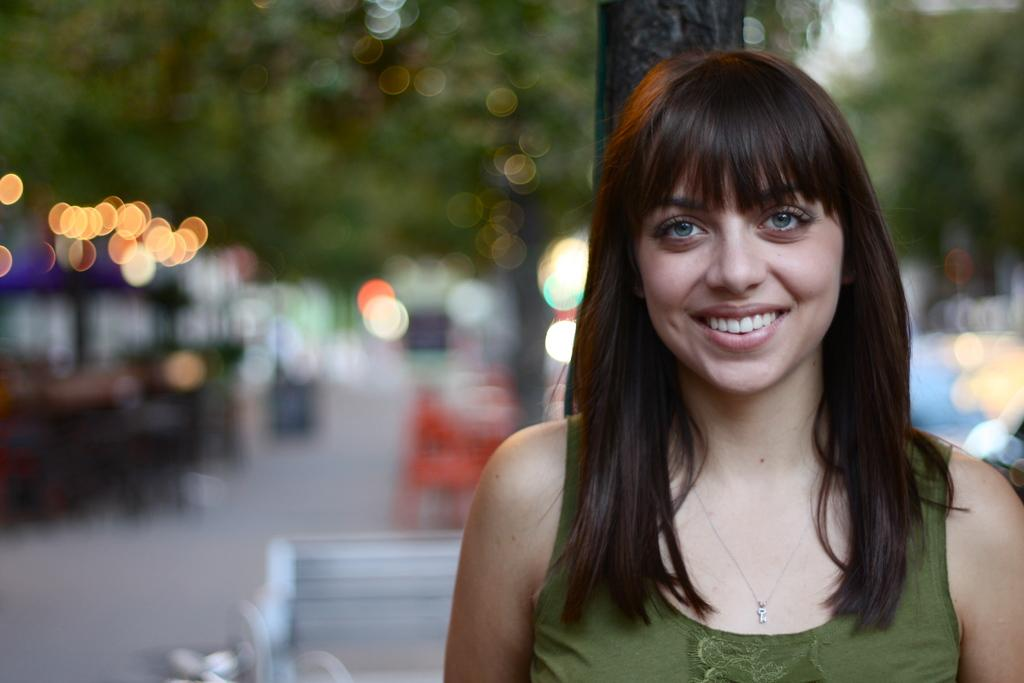Who is present in the image? There is a lady in the image. What can be seen in the background of the image? There are many trees in the image. What object is present for sitting in the image? There is a bench in the image. What type of whip can be seen in the lady's hand in the image? There is no whip present in the image; the lady is not holding any object. What color is the button on the lady's shirt in the image? There is no button mentioned or visible on the lady's clothing in the image. 